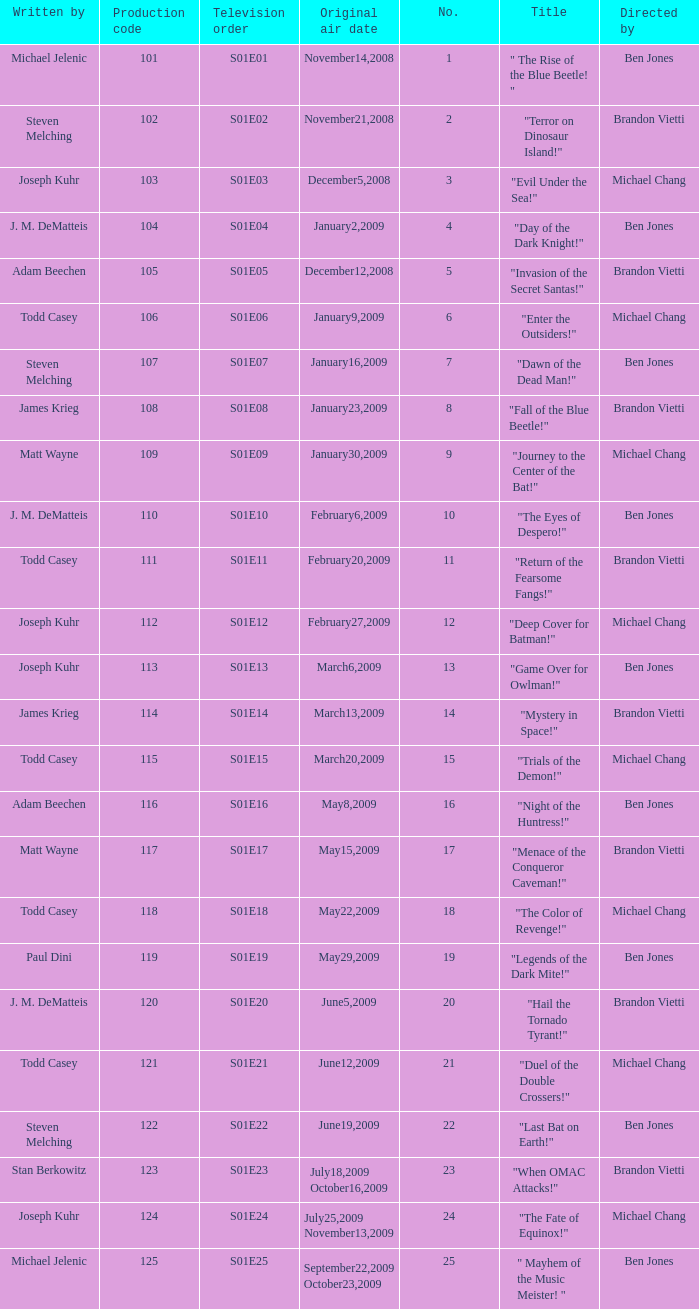Who directed s01e13 Ben Jones. 